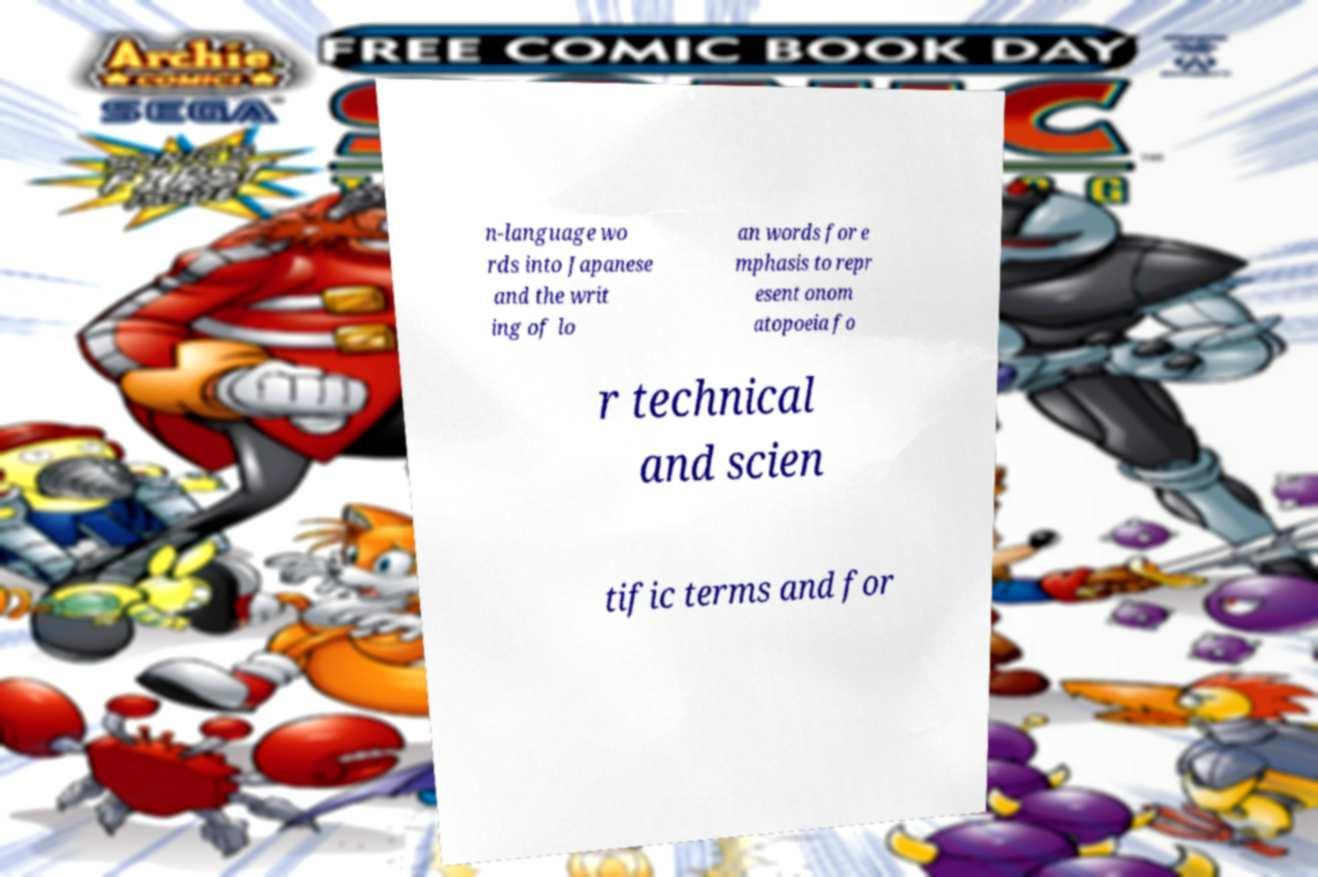I need the written content from this picture converted into text. Can you do that? n-language wo rds into Japanese and the writ ing of lo an words for e mphasis to repr esent onom atopoeia fo r technical and scien tific terms and for 